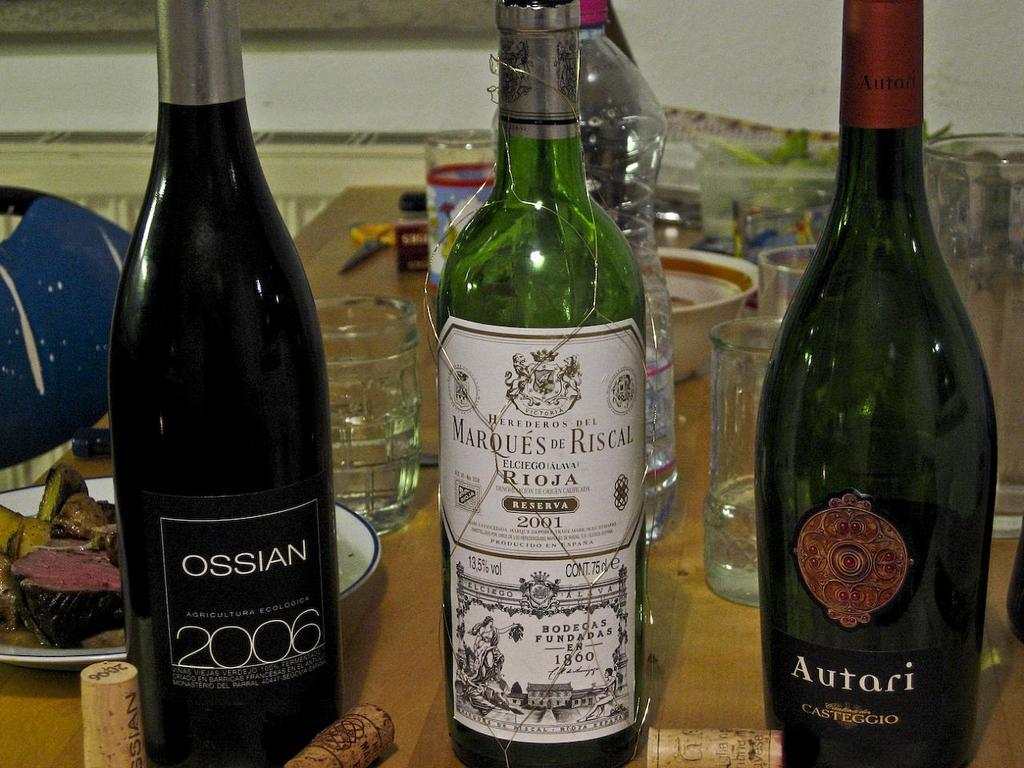Provide a one-sentence caption for the provided image. A bottle of Ossian 2006 is next to two other alcohol bottles on a crowded table. 